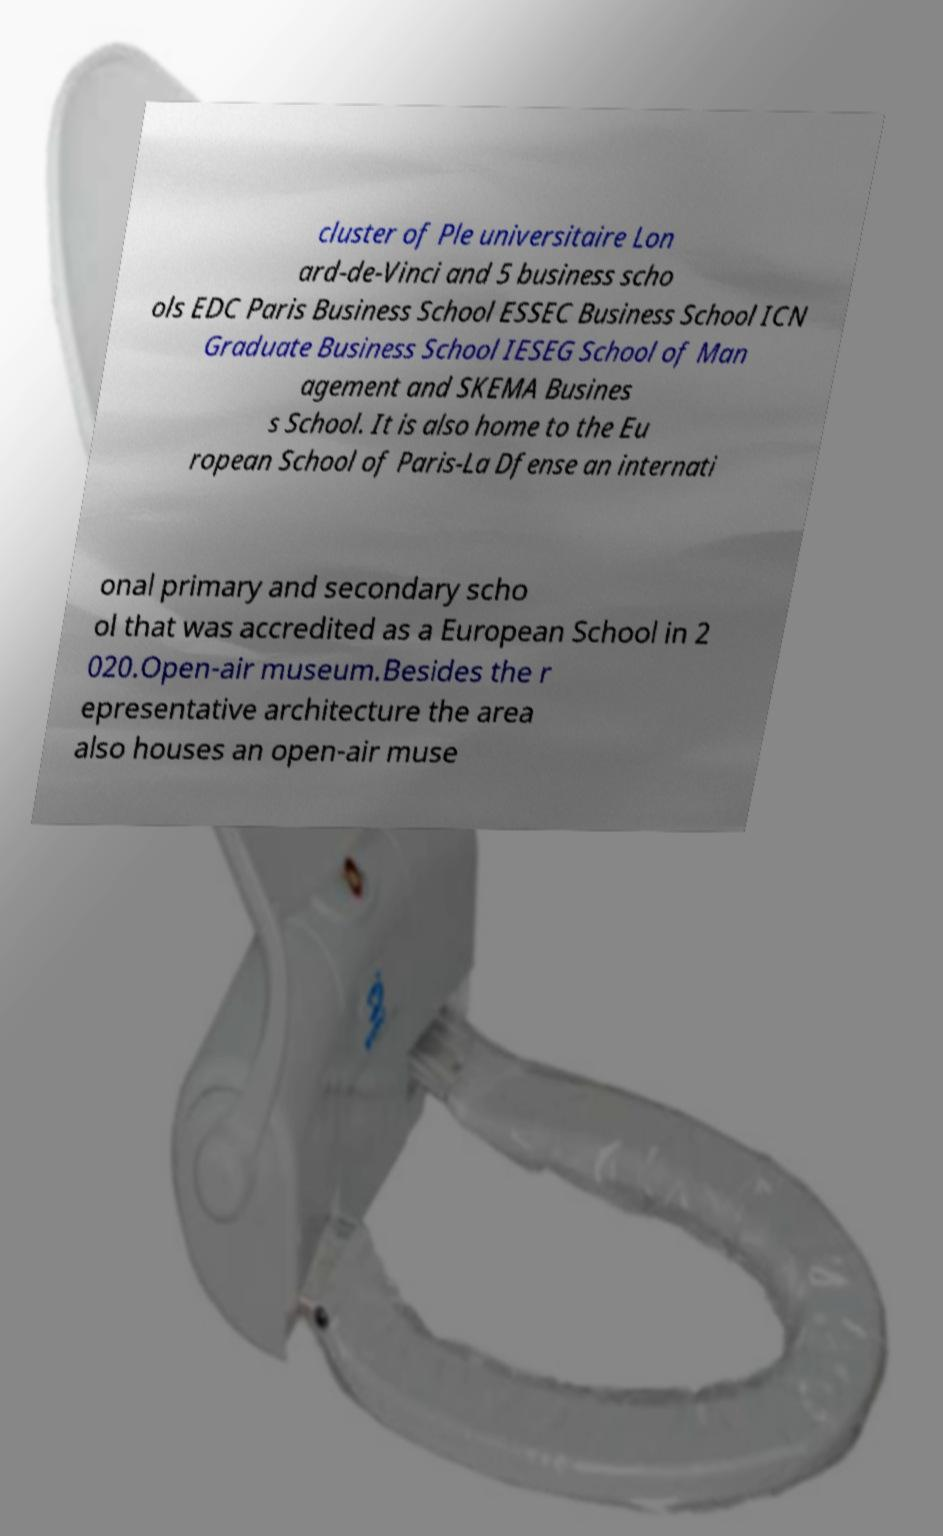What messages or text are displayed in this image? I need them in a readable, typed format. cluster of Ple universitaire Lon ard-de-Vinci and 5 business scho ols EDC Paris Business School ESSEC Business School ICN Graduate Business School IESEG School of Man agement and SKEMA Busines s School. It is also home to the Eu ropean School of Paris-La Dfense an internati onal primary and secondary scho ol that was accredited as a European School in 2 020.Open-air museum.Besides the r epresentative architecture the area also houses an open-air muse 